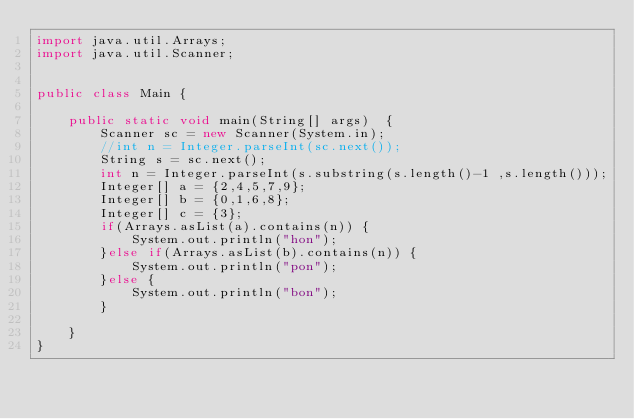Convert code to text. <code><loc_0><loc_0><loc_500><loc_500><_Java_>import java.util.Arrays;
import java.util.Scanner;


public class Main {

	public static void main(String[] args)  {
		Scanner sc = new Scanner(System.in);
		//int n = Integer.parseInt(sc.next());
		String s = sc.next();
		int n = Integer.parseInt(s.substring(s.length()-1 ,s.length()));
		Integer[] a = {2,4,5,7,9};
		Integer[] b = {0,1,6,8};
		Integer[] c = {3};
		if(Arrays.asList(a).contains(n)) {
			System.out.println("hon");
		}else if(Arrays.asList(b).contains(n)) {
			System.out.println("pon");
		}else {
			System.out.println("bon");
		}
		
	}
}
</code> 